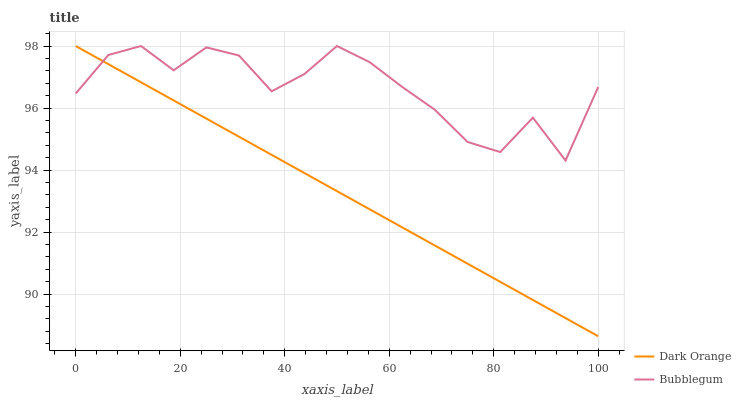Does Dark Orange have the minimum area under the curve?
Answer yes or no. Yes. Does Bubblegum have the maximum area under the curve?
Answer yes or no. Yes. Does Bubblegum have the minimum area under the curve?
Answer yes or no. No. Is Dark Orange the smoothest?
Answer yes or no. Yes. Is Bubblegum the roughest?
Answer yes or no. Yes. Is Bubblegum the smoothest?
Answer yes or no. No. Does Dark Orange have the lowest value?
Answer yes or no. Yes. Does Bubblegum have the lowest value?
Answer yes or no. No. Does Bubblegum have the highest value?
Answer yes or no. Yes. Does Bubblegum intersect Dark Orange?
Answer yes or no. Yes. Is Bubblegum less than Dark Orange?
Answer yes or no. No. Is Bubblegum greater than Dark Orange?
Answer yes or no. No. 